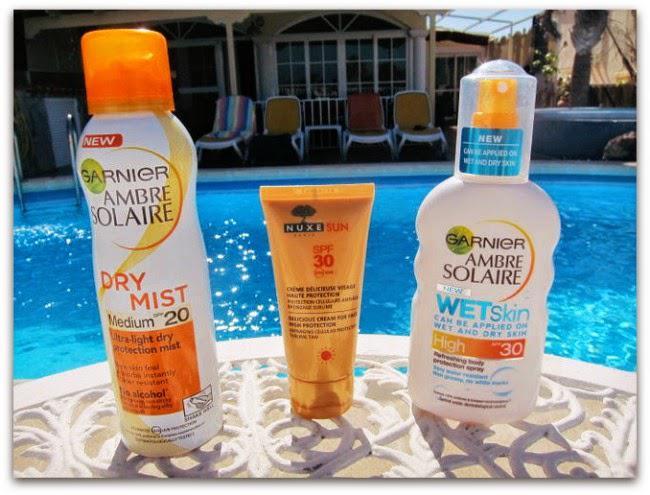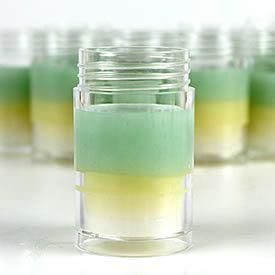The first image is the image on the left, the second image is the image on the right. Assess this claim about the two images: "Three containers are shown in one of the images.". Correct or not? Answer yes or no. Yes. The first image is the image on the left, the second image is the image on the right. Considering the images on both sides, is "One image shows exactly three skincare products, which are in a row and upright." valid? Answer yes or no. Yes. 